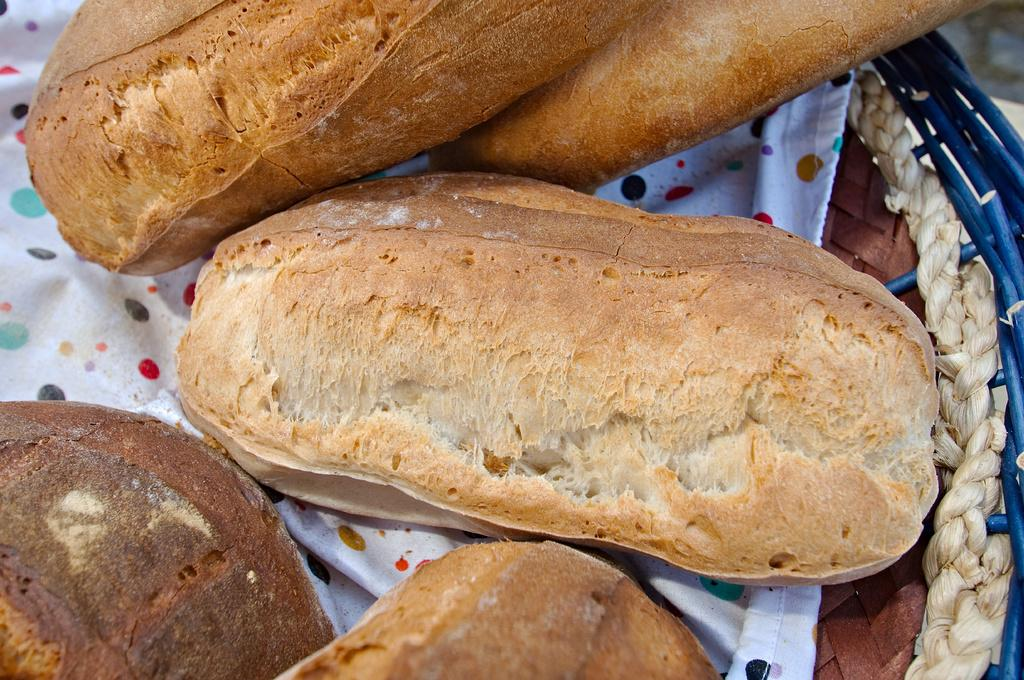What type of items are in the basket in the image? There are food places in a basket in the image. What is the color of the cloth in the image? The cloth in the image is white. What do the food items resemble in appearance? The food looks like buns. What type of soap is visible in the image? There is no soap present in the image. Are there any bushes visible in the image? There are no bushes present in the image. 